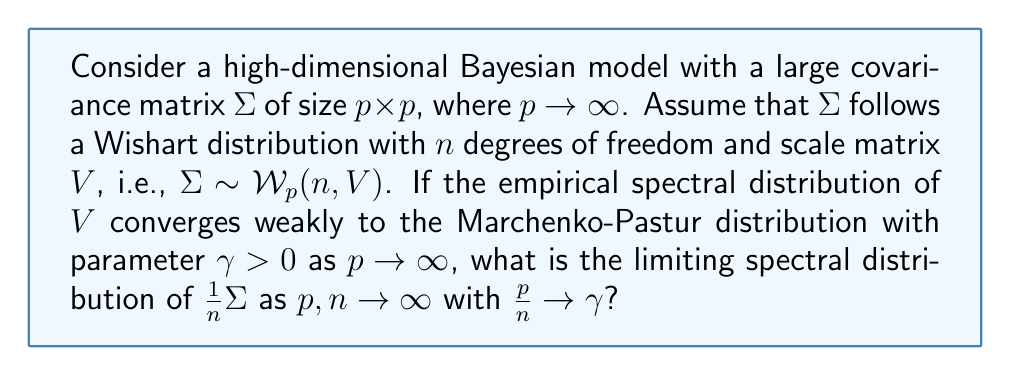Teach me how to tackle this problem. To solve this problem, we'll follow these steps:

1) First, recall that for a Wishart-distributed matrix $\Sigma \sim \mathcal{W}_p(n, V)$, we have $\mathbb{E}[\Sigma] = nV$.

2) The scaling factor $\frac{1}{n}$ in $\frac{1}{n}\Sigma$ suggests that we're dealing with a normalized version of the Wishart matrix.

3) The Marchenko-Pastur distribution is the limiting spectral distribution for sample covariance matrices. In this case, $V$ can be thought of as the population covariance matrix.

4) Given that the empirical spectral distribution of $V$ converges to the Marchenko-Pastur distribution with parameter $\gamma$, we can infer that $V$ itself is approaching a sample covariance matrix structure as $p \to \infty$.

5) The key insight is that $\frac{1}{n}\Sigma$ can be viewed as a sample covariance matrix of a matrix $X$ with i.i.d. entries, where $X$ has covariance $V$.

6) In the limit as $p, n \to \infty$ with $\frac{p}{n} \to \gamma$, the spectral distribution of $\frac{1}{n}\Sigma$ will converge to the free multiplicative convolution of the limiting distribution of $V$ and the Marchenko-Pastur distribution with parameter $\gamma$.

7) The free multiplicative convolution of two Marchenko-Pastur distributions with parameters $\gamma_1$ and $\gamma_2$ is again a Marchenko-Pastur distribution with parameter $\gamma_1\gamma_2$.

8) Therefore, the limiting spectral distribution of $\frac{1}{n}\Sigma$ will be a Marchenko-Pastur distribution with parameter $\gamma^2$.
Answer: Marchenko-Pastur distribution with parameter $\gamma^2$ 